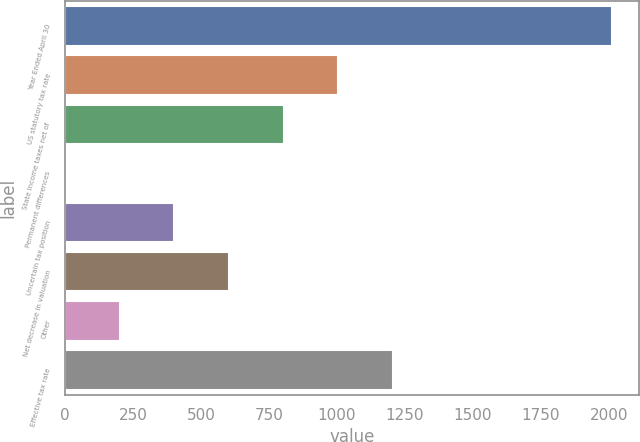Convert chart to OTSL. <chart><loc_0><loc_0><loc_500><loc_500><bar_chart><fcel>Year Ended April 30<fcel>US statutory tax rate<fcel>State income taxes net of<fcel>Permanent differences<fcel>Uncertain tax position<fcel>Net decrease in valuation<fcel>Other<fcel>Effective tax rate<nl><fcel>2010<fcel>1005.25<fcel>804.3<fcel>0.5<fcel>402.4<fcel>603.35<fcel>201.45<fcel>1206.2<nl></chart> 